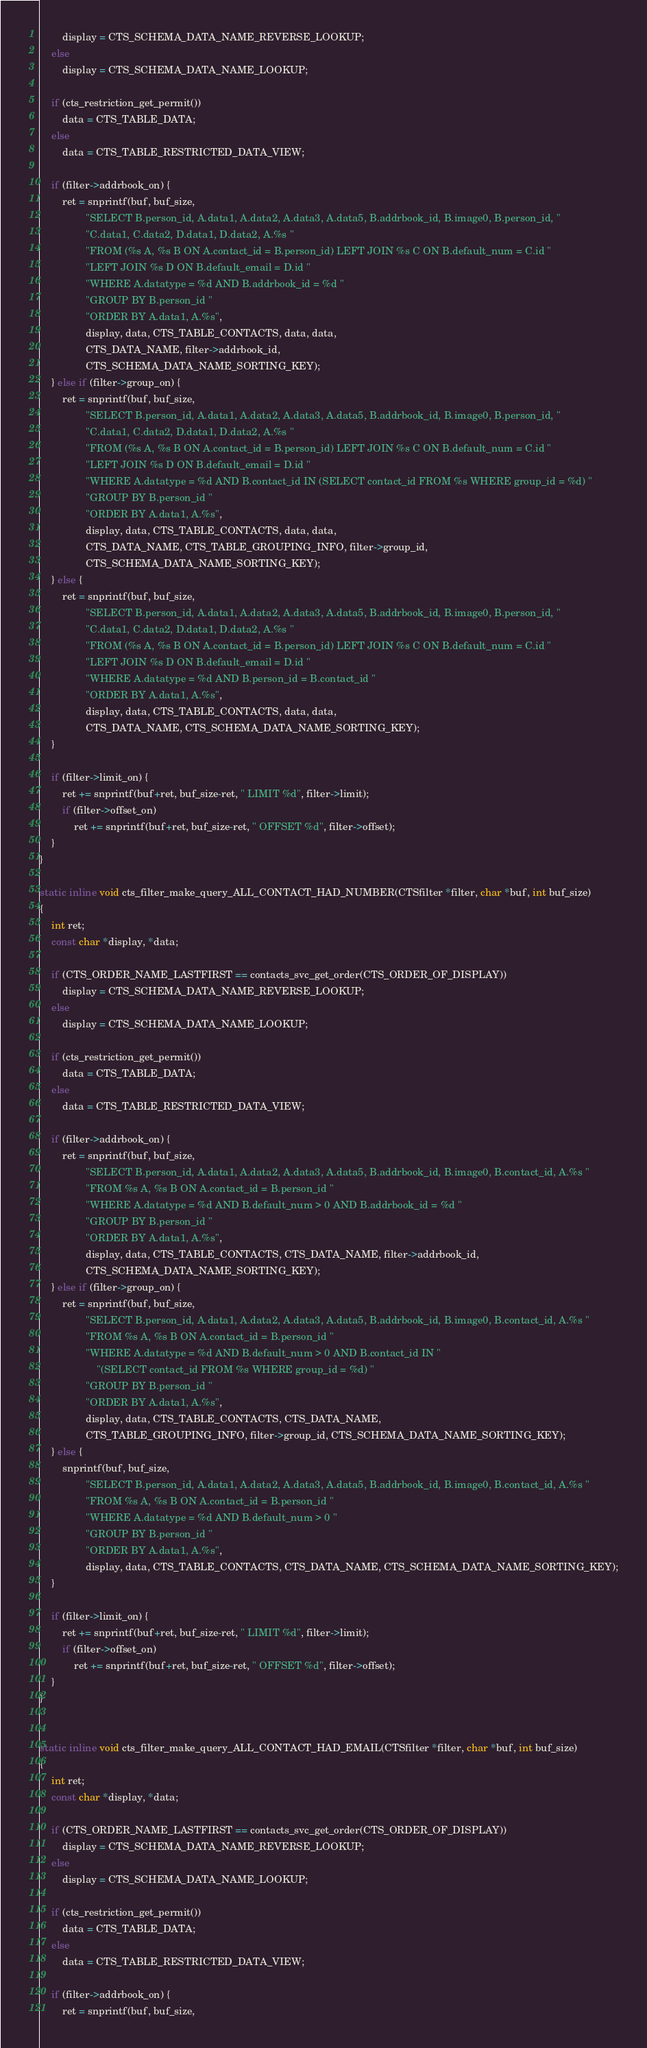Convert code to text. <code><loc_0><loc_0><loc_500><loc_500><_C_>		display = CTS_SCHEMA_DATA_NAME_REVERSE_LOOKUP;
	else
		display = CTS_SCHEMA_DATA_NAME_LOOKUP;

	if (cts_restriction_get_permit())
		data = CTS_TABLE_DATA;
	else
		data = CTS_TABLE_RESTRICTED_DATA_VIEW;

	if (filter->addrbook_on) {
		ret = snprintf(buf, buf_size,
				"SELECT B.person_id, A.data1, A.data2, A.data3, A.data5, B.addrbook_id, B.image0, B.person_id, "
				"C.data1, C.data2, D.data1, D.data2, A.%s "
				"FROM (%s A, %s B ON A.contact_id = B.person_id) LEFT JOIN %s C ON B.default_num = C.id "
				"LEFT JOIN %s D ON B.default_email = D.id "
				"WHERE A.datatype = %d AND B.addrbook_id = %d "
				"GROUP BY B.person_id "
				"ORDER BY A.data1, A.%s",
				display, data, CTS_TABLE_CONTACTS, data, data,
				CTS_DATA_NAME, filter->addrbook_id,
				CTS_SCHEMA_DATA_NAME_SORTING_KEY);
	} else if (filter->group_on) {
		ret = snprintf(buf, buf_size,
				"SELECT B.person_id, A.data1, A.data2, A.data3, A.data5, B.addrbook_id, B.image0, B.person_id, "
				"C.data1, C.data2, D.data1, D.data2, A.%s "
				"FROM (%s A, %s B ON A.contact_id = B.person_id) LEFT JOIN %s C ON B.default_num = C.id "
				"LEFT JOIN %s D ON B.default_email = D.id "
				"WHERE A.datatype = %d AND B.contact_id IN (SELECT contact_id FROM %s WHERE group_id = %d) "
				"GROUP BY B.person_id "
				"ORDER BY A.data1, A.%s",
				display, data, CTS_TABLE_CONTACTS, data, data,
				CTS_DATA_NAME, CTS_TABLE_GROUPING_INFO, filter->group_id,
				CTS_SCHEMA_DATA_NAME_SORTING_KEY);
	} else {
		ret = snprintf(buf, buf_size,
				"SELECT B.person_id, A.data1, A.data2, A.data3, A.data5, B.addrbook_id, B.image0, B.person_id, "
				"C.data1, C.data2, D.data1, D.data2, A.%s "
				"FROM (%s A, %s B ON A.contact_id = B.person_id) LEFT JOIN %s C ON B.default_num = C.id "
				"LEFT JOIN %s D ON B.default_email = D.id "
				"WHERE A.datatype = %d AND B.person_id = B.contact_id "
				"ORDER BY A.data1, A.%s",
				display, data, CTS_TABLE_CONTACTS, data, data,
				CTS_DATA_NAME, CTS_SCHEMA_DATA_NAME_SORTING_KEY);
	}

	if (filter->limit_on) {
		ret += snprintf(buf+ret, buf_size-ret, " LIMIT %d", filter->limit);
		if (filter->offset_on)
			ret += snprintf(buf+ret, buf_size-ret, " OFFSET %d", filter->offset);
	}
}

static inline void cts_filter_make_query_ALL_CONTACT_HAD_NUMBER(CTSfilter *filter, char *buf, int buf_size)
{
	int ret;
	const char *display, *data;

	if (CTS_ORDER_NAME_LASTFIRST == contacts_svc_get_order(CTS_ORDER_OF_DISPLAY))
		display = CTS_SCHEMA_DATA_NAME_REVERSE_LOOKUP;
	else
		display = CTS_SCHEMA_DATA_NAME_LOOKUP;

	if (cts_restriction_get_permit())
		data = CTS_TABLE_DATA;
	else
		data = CTS_TABLE_RESTRICTED_DATA_VIEW;

	if (filter->addrbook_on) {
		ret = snprintf(buf, buf_size,
				"SELECT B.person_id, A.data1, A.data2, A.data3, A.data5, B.addrbook_id, B.image0, B.contact_id, A.%s "
				"FROM %s A, %s B ON A.contact_id = B.person_id "
				"WHERE A.datatype = %d AND B.default_num > 0 AND B.addrbook_id = %d "
				"GROUP BY B.person_id "
				"ORDER BY A.data1, A.%s",
				display, data, CTS_TABLE_CONTACTS, CTS_DATA_NAME, filter->addrbook_id,
				CTS_SCHEMA_DATA_NAME_SORTING_KEY);
	} else if (filter->group_on) {
		ret = snprintf(buf, buf_size,
				"SELECT B.person_id, A.data1, A.data2, A.data3, A.data5, B.addrbook_id, B.image0, B.contact_id, A.%s "
				"FROM %s A, %s B ON A.contact_id = B.person_id "
				"WHERE A.datatype = %d AND B.default_num > 0 AND B.contact_id IN "
					"(SELECT contact_id FROM %s WHERE group_id = %d) "
				"GROUP BY B.person_id "
				"ORDER BY A.data1, A.%s",
				display, data, CTS_TABLE_CONTACTS, CTS_DATA_NAME,
				CTS_TABLE_GROUPING_INFO, filter->group_id, CTS_SCHEMA_DATA_NAME_SORTING_KEY);
	} else {
		snprintf(buf, buf_size,
				"SELECT B.person_id, A.data1, A.data2, A.data3, A.data5, B.addrbook_id, B.image0, B.contact_id, A.%s "
				"FROM %s A, %s B ON A.contact_id = B.person_id "
				"WHERE A.datatype = %d AND B.default_num > 0 "
				"GROUP BY B.person_id "
				"ORDER BY A.data1, A.%s",
				display, data, CTS_TABLE_CONTACTS, CTS_DATA_NAME, CTS_SCHEMA_DATA_NAME_SORTING_KEY);
	}

	if (filter->limit_on) {
		ret += snprintf(buf+ret, buf_size-ret, " LIMIT %d", filter->limit);
		if (filter->offset_on)
			ret += snprintf(buf+ret, buf_size-ret, " OFFSET %d", filter->offset);
	}
}


static inline void cts_filter_make_query_ALL_CONTACT_HAD_EMAIL(CTSfilter *filter, char *buf, int buf_size)
{
	int ret;
	const char *display, *data;

	if (CTS_ORDER_NAME_LASTFIRST == contacts_svc_get_order(CTS_ORDER_OF_DISPLAY))
		display = CTS_SCHEMA_DATA_NAME_REVERSE_LOOKUP;
	else
		display = CTS_SCHEMA_DATA_NAME_LOOKUP;

	if (cts_restriction_get_permit())
		data = CTS_TABLE_DATA;
	else
		data = CTS_TABLE_RESTRICTED_DATA_VIEW;

	if (filter->addrbook_on) {
		ret = snprintf(buf, buf_size,</code> 